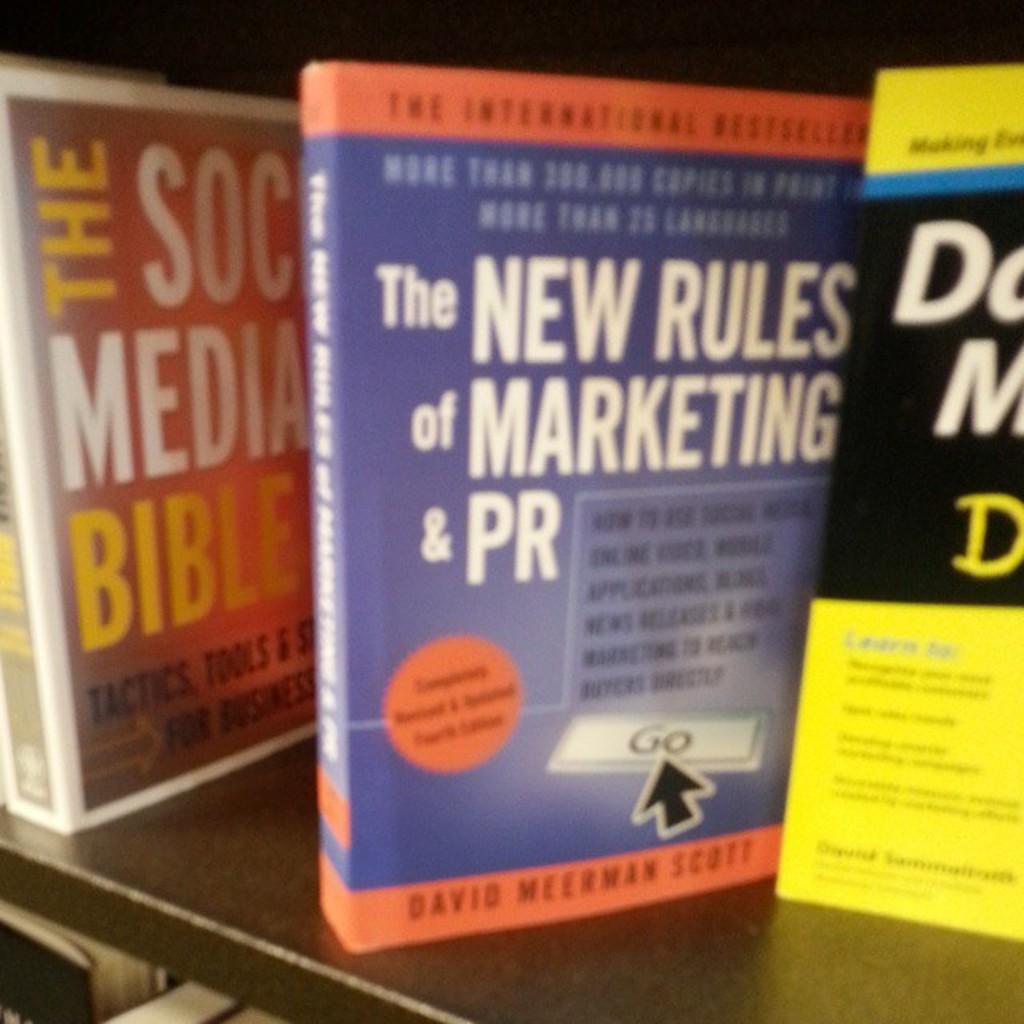Who wrote the book in blue?
Your answer should be compact. David meerman scott. What is the blue book about?
Your response must be concise. The new rules of marketing & pr. 